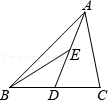With the midpoints D and E creating smaller triangles within triangle ABC, what would be the overall implications on the triangle's geometry if point E were not placed precisely at the midpoint? If point E were not positioned at the midpoint of AD in triangle ABC, the symmetry that previously divided the triangle into congruent parts would be disrupted. This change would subsequently alter the proportional areas of the triangles formed by lines AD, DE, and BE. The non-midpoint placement of E would therefore shift the equal division of areas, potentially complicating the process of calculating the area of each internal triangle as it deviates from the straightforward calculation enabled by midpoints. How would the geometric properties and angles change in triangle ABE if point E shifts from its midpoint position? Shifting point E away from the midpoint of AD affects the internal angles of triangle ABE significantly. Originally, the angle bisectors and symmetry in triangle ABE due to midpoint location ensure specific angle values which contribute to its congruence with triangle BDE. Moving E would skew these angles, altering their measures and disturbing the internal consistency of angles, which directly influences the calculations related to triangle properties like area and perimeter. 